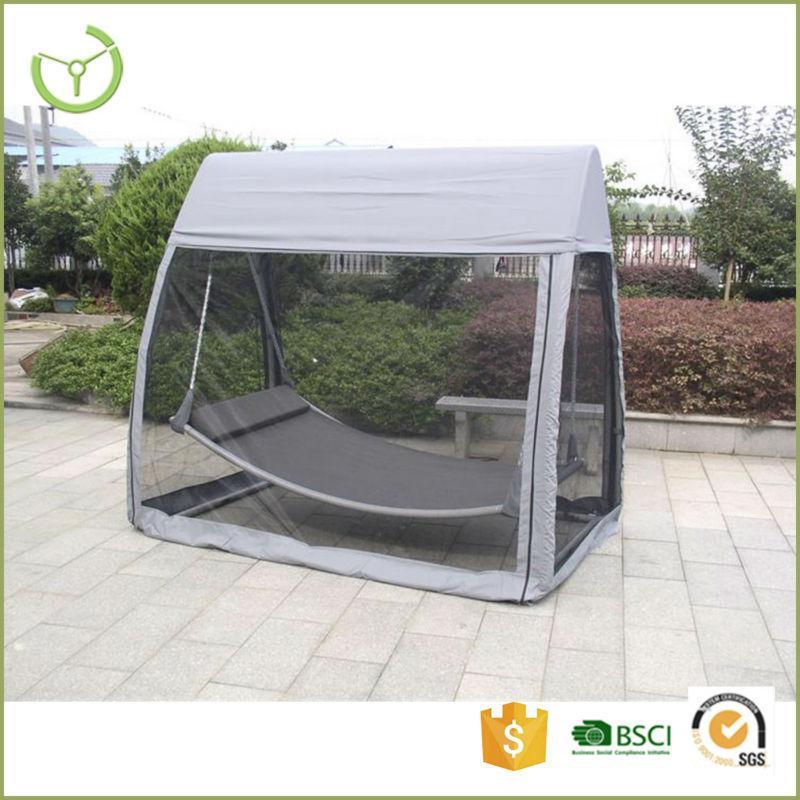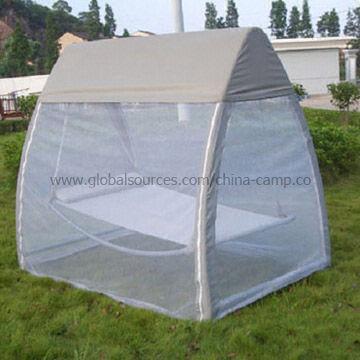The first image is the image on the left, the second image is the image on the right. For the images displayed, is the sentence "Both tents are shown without a background." factually correct? Answer yes or no. No. The first image is the image on the left, the second image is the image on the right. Assess this claim about the two images: "The structure in one of the images is standing upon a tiled floor.". Correct or not? Answer yes or no. Yes. 